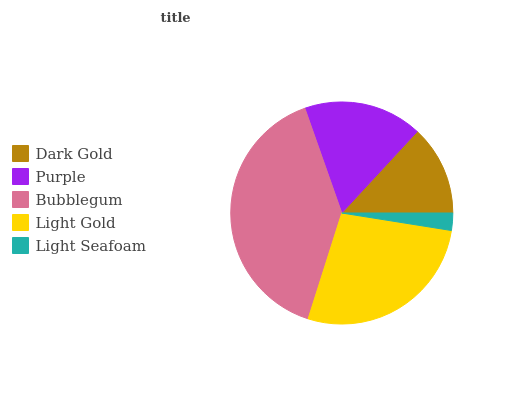Is Light Seafoam the minimum?
Answer yes or no. Yes. Is Bubblegum the maximum?
Answer yes or no. Yes. Is Purple the minimum?
Answer yes or no. No. Is Purple the maximum?
Answer yes or no. No. Is Purple greater than Dark Gold?
Answer yes or no. Yes. Is Dark Gold less than Purple?
Answer yes or no. Yes. Is Dark Gold greater than Purple?
Answer yes or no. No. Is Purple less than Dark Gold?
Answer yes or no. No. Is Purple the high median?
Answer yes or no. Yes. Is Purple the low median?
Answer yes or no. Yes. Is Dark Gold the high median?
Answer yes or no. No. Is Bubblegum the low median?
Answer yes or no. No. 